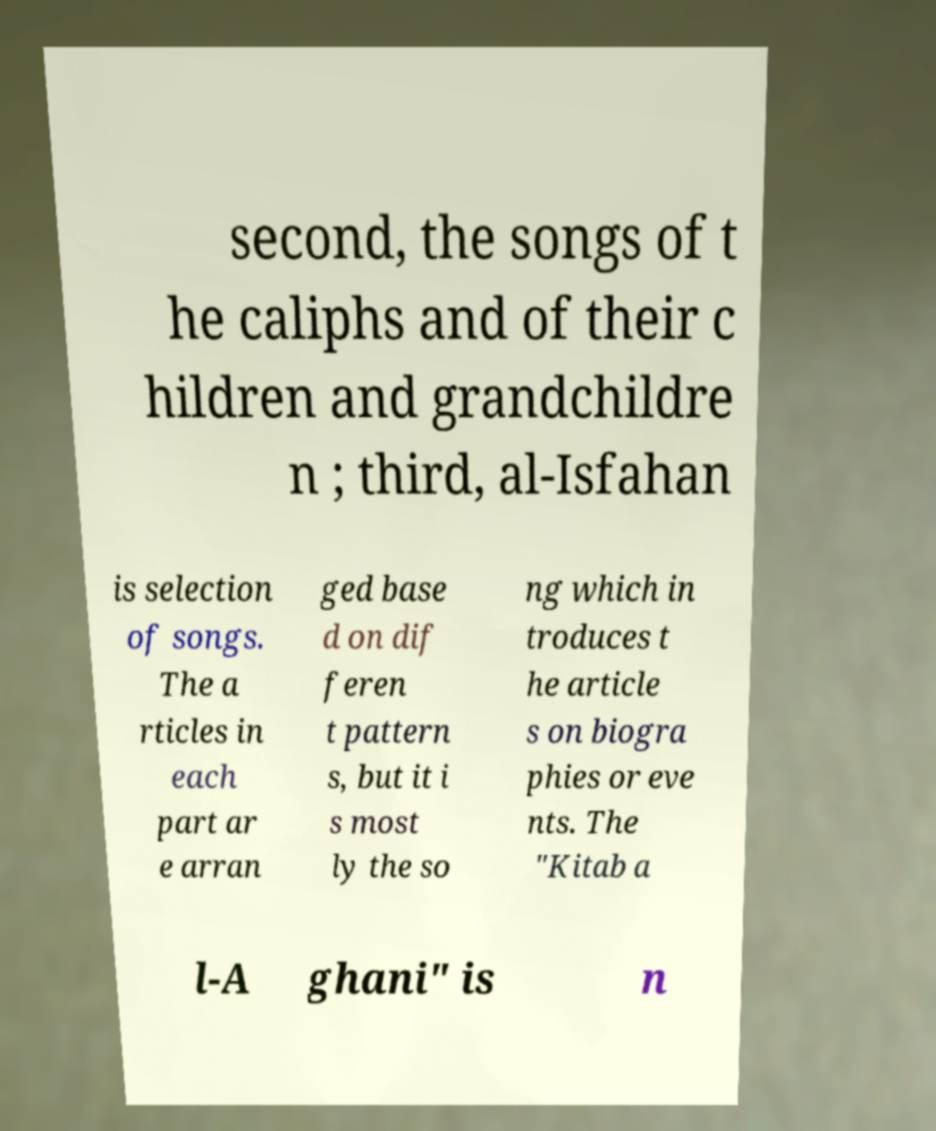Can you read and provide the text displayed in the image?This photo seems to have some interesting text. Can you extract and type it out for me? second, the songs of t he caliphs and of their c hildren and grandchildre n ; third, al-Isfahan is selection of songs. The a rticles in each part ar e arran ged base d on dif feren t pattern s, but it i s most ly the so ng which in troduces t he article s on biogra phies or eve nts. The "Kitab a l-A ghani" is n 